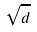Convert formula to latex. <formula><loc_0><loc_0><loc_500><loc_500>\sqrt { d }</formula> 